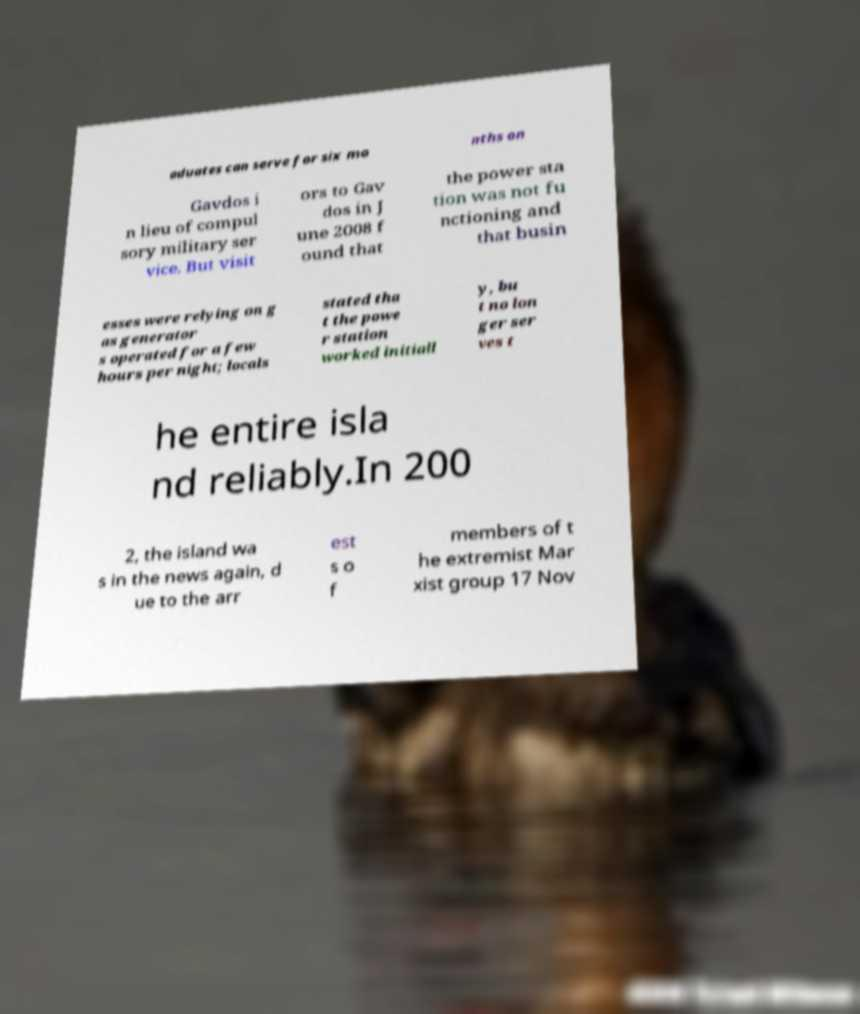Can you read and provide the text displayed in the image?This photo seems to have some interesting text. Can you extract and type it out for me? aduates can serve for six mo nths on Gavdos i n lieu of compul sory military ser vice. But visit ors to Gav dos in J une 2008 f ound that the power sta tion was not fu nctioning and that busin esses were relying on g as generator s operated for a few hours per night; locals stated tha t the powe r station worked initiall y, bu t no lon ger ser ves t he entire isla nd reliably.In 200 2, the island wa s in the news again, d ue to the arr est s o f members of t he extremist Mar xist group 17 Nov 